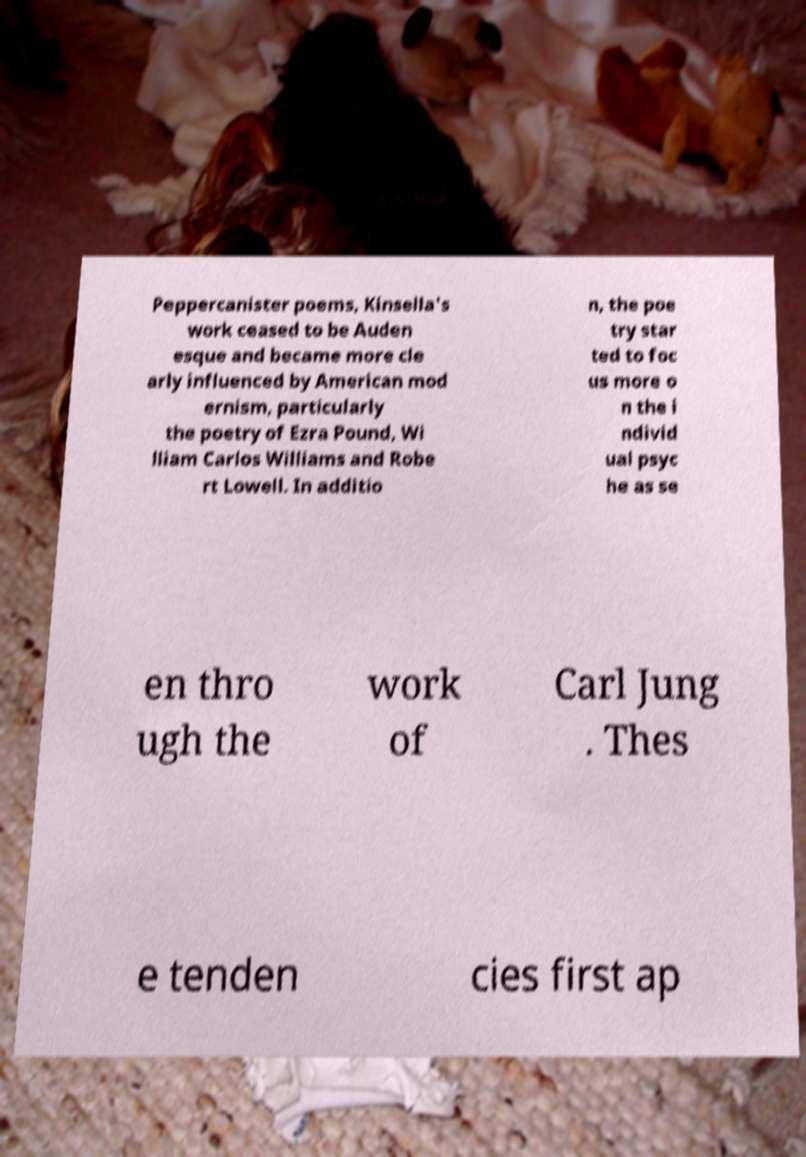Can you accurately transcribe the text from the provided image for me? Peppercanister poems, Kinsella's work ceased to be Auden esque and became more cle arly influenced by American mod ernism, particularly the poetry of Ezra Pound, Wi lliam Carlos Williams and Robe rt Lowell. In additio n, the poe try star ted to foc us more o n the i ndivid ual psyc he as se en thro ugh the work of Carl Jung . Thes e tenden cies first ap 